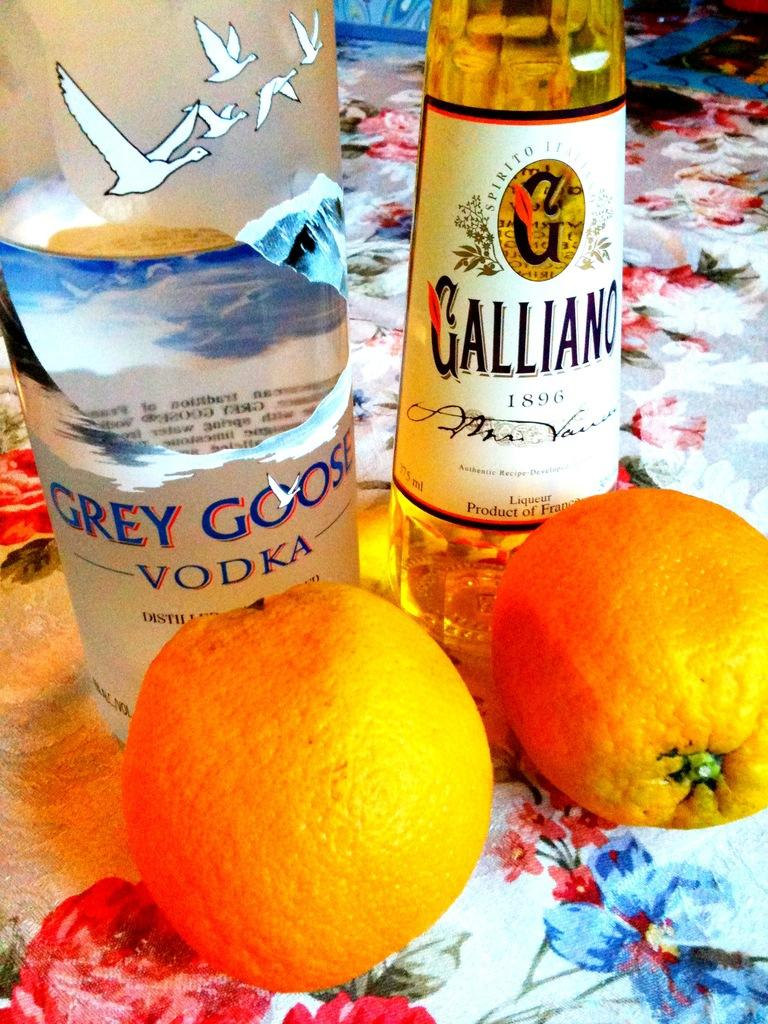What objects are present in the image that are made of glass? There are two glass bottles in the image. Where are the glass bottles located in the image? The glass bottles are placed on a surface. What type of fruit is present in the image? There are two oranges in the image. How are the oranges positioned in relation to the glass bottles? The oranges are placed in front of the glass bottles. What part of the body is used to slip the drain in the image? There is no part of the body or drain present in the image. 